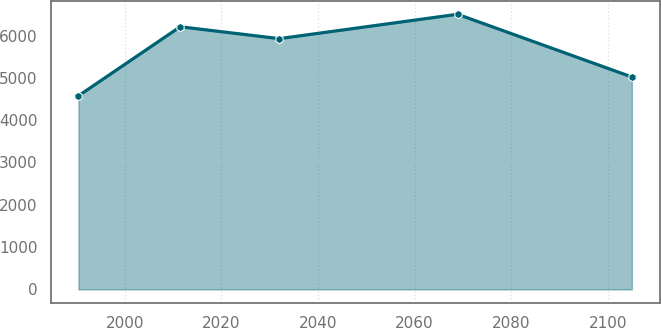<chart> <loc_0><loc_0><loc_500><loc_500><line_chart><ecel><fcel>Unnamed: 1<nl><fcel>1990.38<fcel>4575.1<nl><fcel>2011.45<fcel>6206.95<nl><fcel>2031.97<fcel>5925.83<nl><fcel>2068.88<fcel>6502.06<nl><fcel>2104.98<fcel>5020.03<nl></chart> 